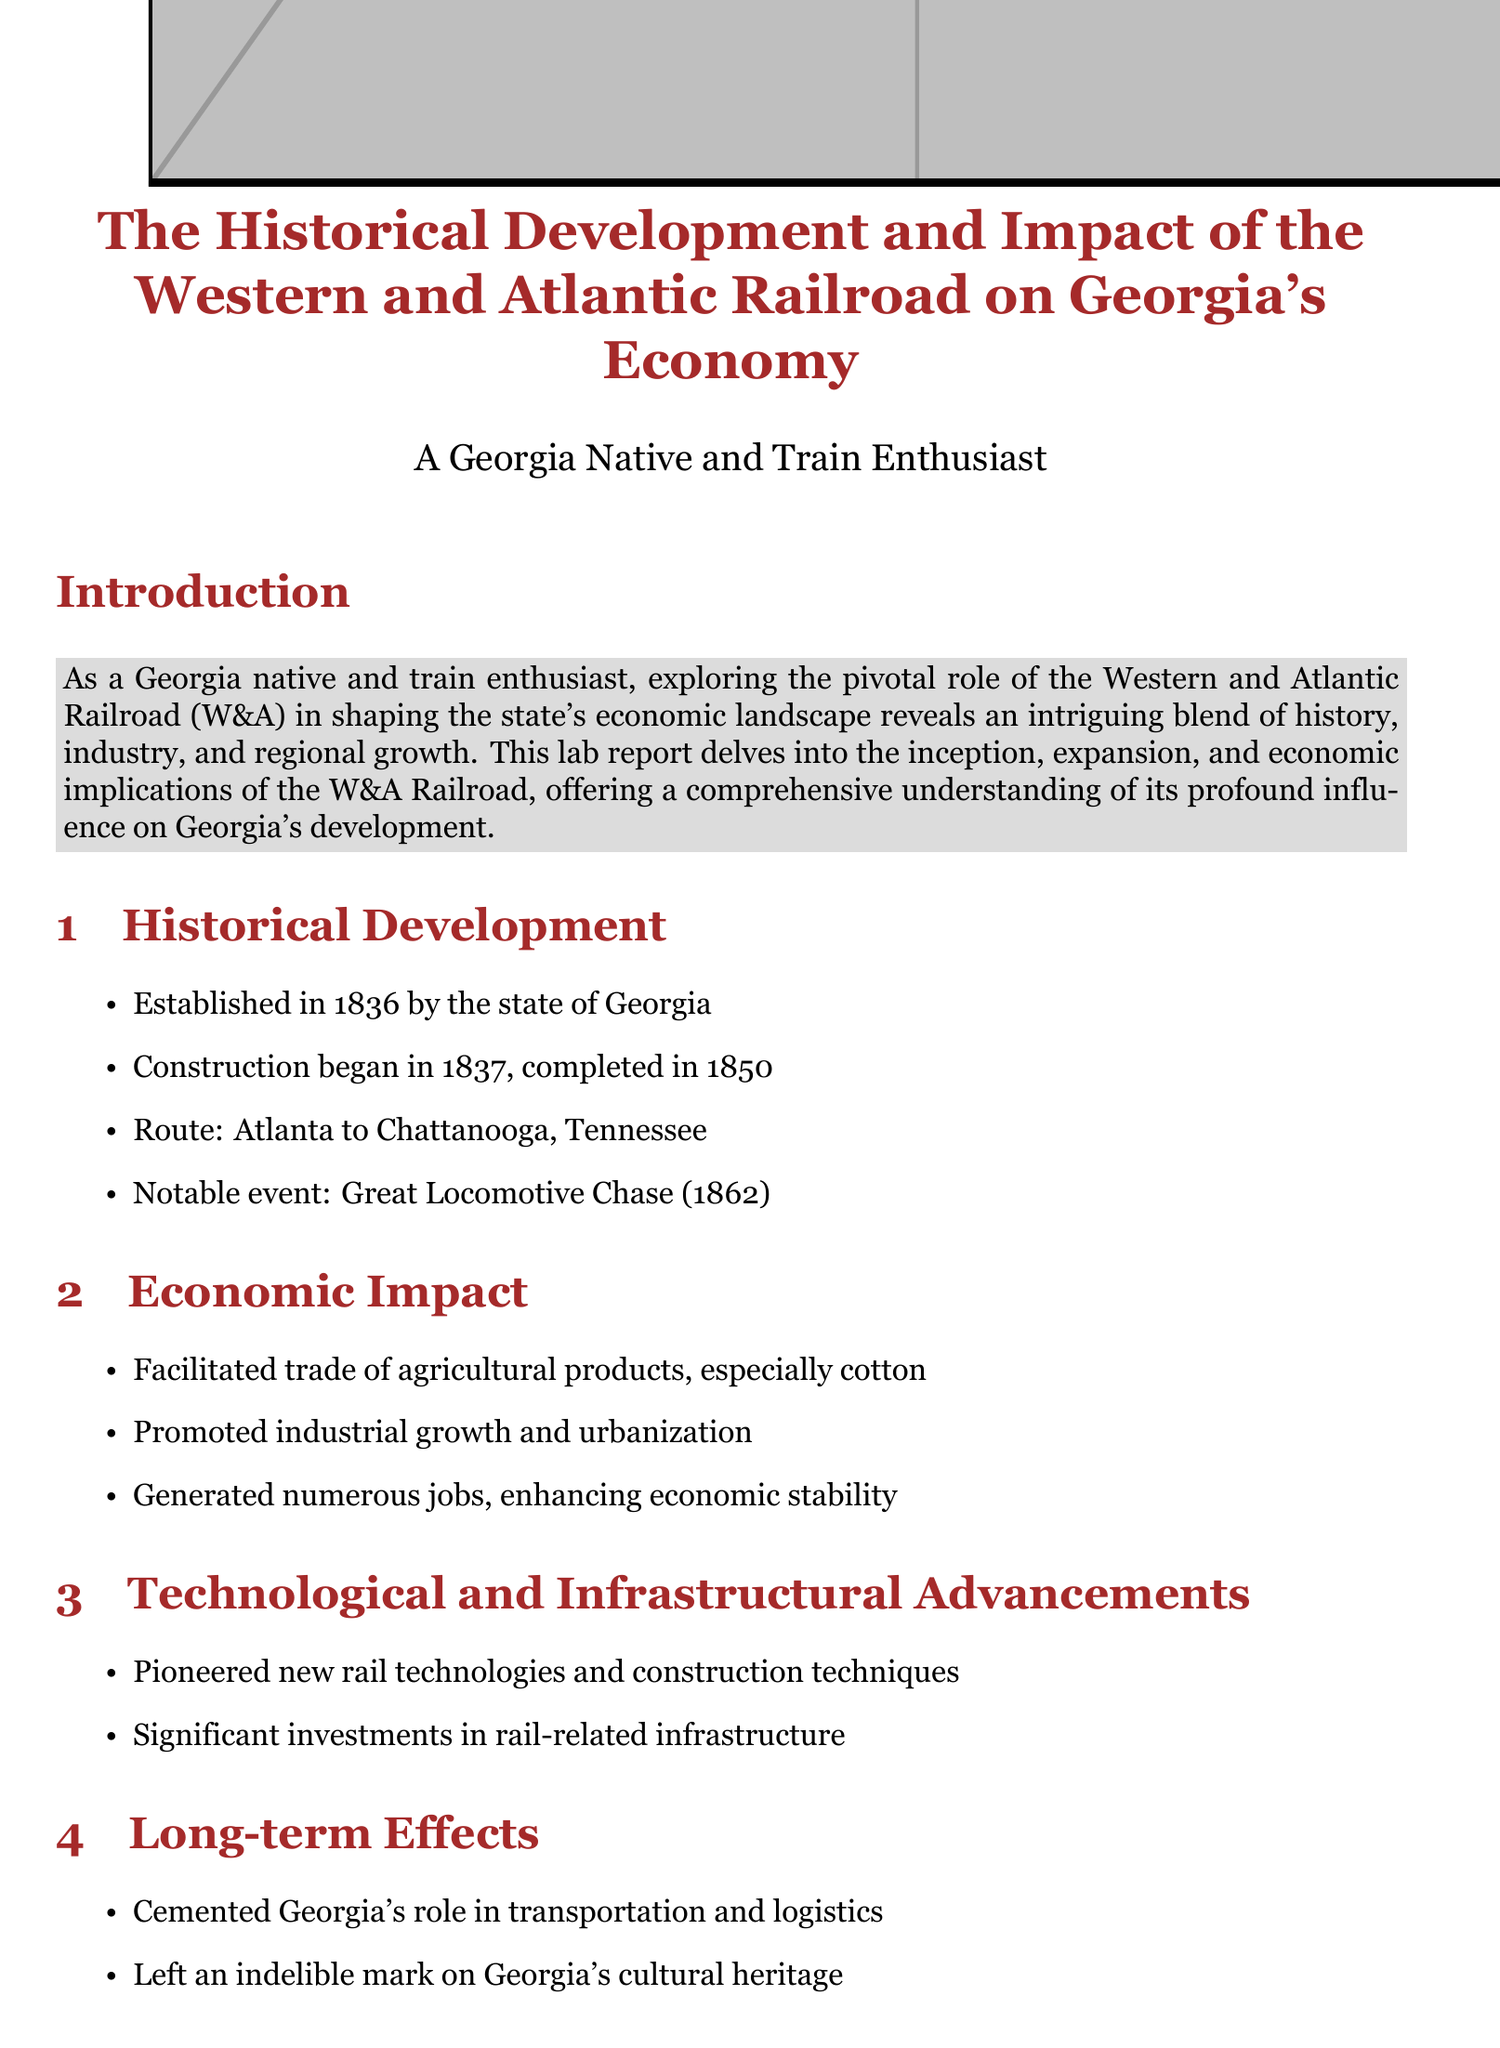What year was the Western and Atlantic Railroad established? The document states that the Western and Atlantic Railroad was established in 1836.
Answer: 1836 When was the construction of the Western and Atlantic Railroad completed? According to the document, the construction was completed in 1850.
Answer: 1850 What was the significance of the Great Locomotive Chase? The document notes that the Great Locomotive Chase was a notable event related to the Western and Atlantic Railroad in 1862.
Answer: 1862 What agricultural product was primarily facilitated by the W&A Railroad? The document indicates that the W&A Railroad facilitated the trade of cotton as an agricultural product.
Answer: cotton How did the W&A Railroad affect job creation in Georgia? The document mentions that the railroad generated numerous jobs, enhancing economic stability.
Answer: generating jobs What technological advancements did the W&A Railroad pioneer? The document explains that it pioneered new rail technologies and construction techniques.
Answer: new rail technologies What was one long-term effect of the W&A Railroad on Georgia? The document states that it cemented Georgia's role in transportation and logistics.
Answer: transportation and logistics What document type is this text? The structure and content indicate it is a lab report.
Answer: lab report 